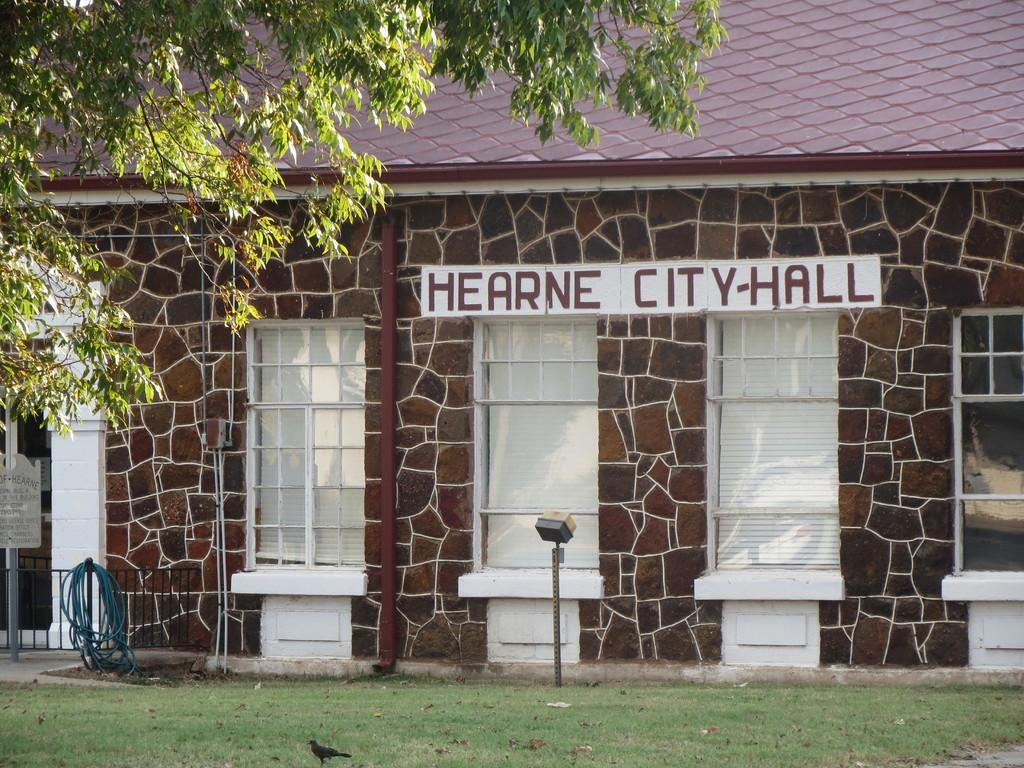What is there is a structure visible in the image, what is it? There is a building in the image. What is located in front of the building? There is a tree in front of the building. Can you describe any living creatures present in the image? Yes, a bird is standing on the surface of the grass in the image. How many eyes can be seen on the bird in the image? There is no indication of the number of eyes on the bird in the image, as it is not possible to see the bird's eyes clearly. 